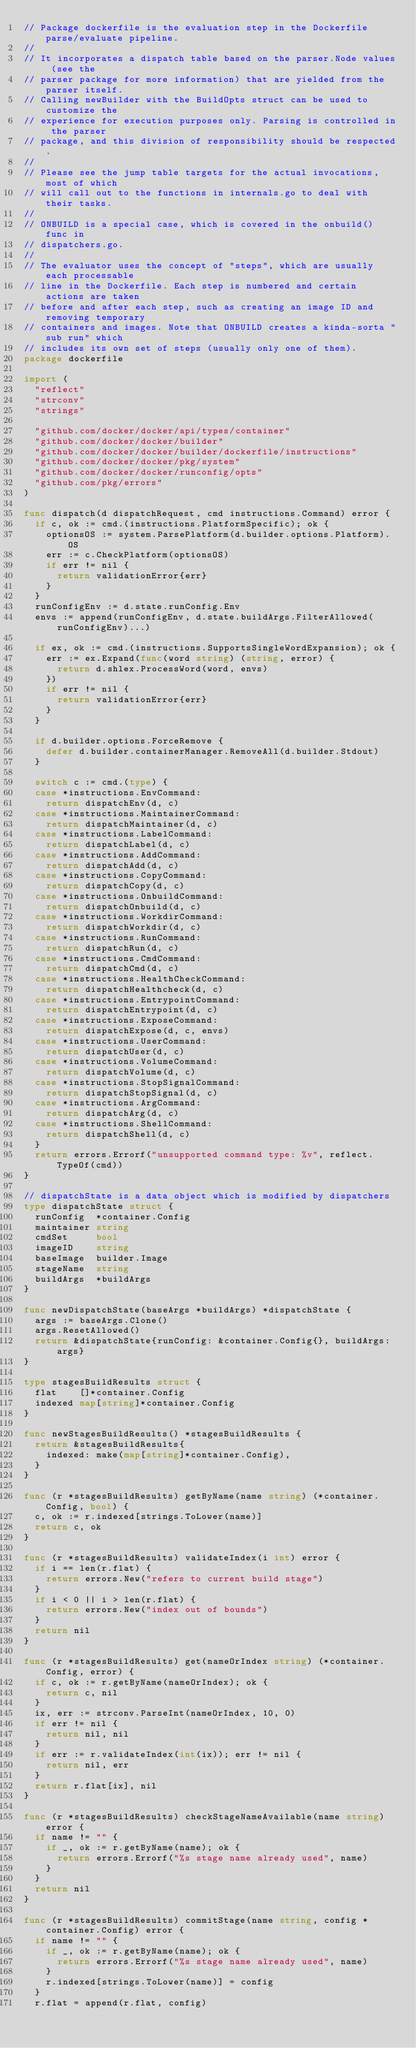Convert code to text. <code><loc_0><loc_0><loc_500><loc_500><_Go_>// Package dockerfile is the evaluation step in the Dockerfile parse/evaluate pipeline.
//
// It incorporates a dispatch table based on the parser.Node values (see the
// parser package for more information) that are yielded from the parser itself.
// Calling newBuilder with the BuildOpts struct can be used to customize the
// experience for execution purposes only. Parsing is controlled in the parser
// package, and this division of responsibility should be respected.
//
// Please see the jump table targets for the actual invocations, most of which
// will call out to the functions in internals.go to deal with their tasks.
//
// ONBUILD is a special case, which is covered in the onbuild() func in
// dispatchers.go.
//
// The evaluator uses the concept of "steps", which are usually each processable
// line in the Dockerfile. Each step is numbered and certain actions are taken
// before and after each step, such as creating an image ID and removing temporary
// containers and images. Note that ONBUILD creates a kinda-sorta "sub run" which
// includes its own set of steps (usually only one of them).
package dockerfile

import (
	"reflect"
	"strconv"
	"strings"

	"github.com/docker/docker/api/types/container"
	"github.com/docker/docker/builder"
	"github.com/docker/docker/builder/dockerfile/instructions"
	"github.com/docker/docker/pkg/system"
	"github.com/docker/docker/runconfig/opts"
	"github.com/pkg/errors"
)

func dispatch(d dispatchRequest, cmd instructions.Command) error {
	if c, ok := cmd.(instructions.PlatformSpecific); ok {
		optionsOS := system.ParsePlatform(d.builder.options.Platform).OS
		err := c.CheckPlatform(optionsOS)
		if err != nil {
			return validationError{err}
		}
	}
	runConfigEnv := d.state.runConfig.Env
	envs := append(runConfigEnv, d.state.buildArgs.FilterAllowed(runConfigEnv)...)

	if ex, ok := cmd.(instructions.SupportsSingleWordExpansion); ok {
		err := ex.Expand(func(word string) (string, error) {
			return d.shlex.ProcessWord(word, envs)
		})
		if err != nil {
			return validationError{err}
		}
	}

	if d.builder.options.ForceRemove {
		defer d.builder.containerManager.RemoveAll(d.builder.Stdout)
	}

	switch c := cmd.(type) {
	case *instructions.EnvCommand:
		return dispatchEnv(d, c)
	case *instructions.MaintainerCommand:
		return dispatchMaintainer(d, c)
	case *instructions.LabelCommand:
		return dispatchLabel(d, c)
	case *instructions.AddCommand:
		return dispatchAdd(d, c)
	case *instructions.CopyCommand:
		return dispatchCopy(d, c)
	case *instructions.OnbuildCommand:
		return dispatchOnbuild(d, c)
	case *instructions.WorkdirCommand:
		return dispatchWorkdir(d, c)
	case *instructions.RunCommand:
		return dispatchRun(d, c)
	case *instructions.CmdCommand:
		return dispatchCmd(d, c)
	case *instructions.HealthCheckCommand:
		return dispatchHealthcheck(d, c)
	case *instructions.EntrypointCommand:
		return dispatchEntrypoint(d, c)
	case *instructions.ExposeCommand:
		return dispatchExpose(d, c, envs)
	case *instructions.UserCommand:
		return dispatchUser(d, c)
	case *instructions.VolumeCommand:
		return dispatchVolume(d, c)
	case *instructions.StopSignalCommand:
		return dispatchStopSignal(d, c)
	case *instructions.ArgCommand:
		return dispatchArg(d, c)
	case *instructions.ShellCommand:
		return dispatchShell(d, c)
	}
	return errors.Errorf("unsupported command type: %v", reflect.TypeOf(cmd))
}

// dispatchState is a data object which is modified by dispatchers
type dispatchState struct {
	runConfig  *container.Config
	maintainer string
	cmdSet     bool
	imageID    string
	baseImage  builder.Image
	stageName  string
	buildArgs  *buildArgs
}

func newDispatchState(baseArgs *buildArgs) *dispatchState {
	args := baseArgs.Clone()
	args.ResetAllowed()
	return &dispatchState{runConfig: &container.Config{}, buildArgs: args}
}

type stagesBuildResults struct {
	flat    []*container.Config
	indexed map[string]*container.Config
}

func newStagesBuildResults() *stagesBuildResults {
	return &stagesBuildResults{
		indexed: make(map[string]*container.Config),
	}
}

func (r *stagesBuildResults) getByName(name string) (*container.Config, bool) {
	c, ok := r.indexed[strings.ToLower(name)]
	return c, ok
}

func (r *stagesBuildResults) validateIndex(i int) error {
	if i == len(r.flat) {
		return errors.New("refers to current build stage")
	}
	if i < 0 || i > len(r.flat) {
		return errors.New("index out of bounds")
	}
	return nil
}

func (r *stagesBuildResults) get(nameOrIndex string) (*container.Config, error) {
	if c, ok := r.getByName(nameOrIndex); ok {
		return c, nil
	}
	ix, err := strconv.ParseInt(nameOrIndex, 10, 0)
	if err != nil {
		return nil, nil
	}
	if err := r.validateIndex(int(ix)); err != nil {
		return nil, err
	}
	return r.flat[ix], nil
}

func (r *stagesBuildResults) checkStageNameAvailable(name string) error {
	if name != "" {
		if _, ok := r.getByName(name); ok {
			return errors.Errorf("%s stage name already used", name)
		}
	}
	return nil
}

func (r *stagesBuildResults) commitStage(name string, config *container.Config) error {
	if name != "" {
		if _, ok := r.getByName(name); ok {
			return errors.Errorf("%s stage name already used", name)
		}
		r.indexed[strings.ToLower(name)] = config
	}
	r.flat = append(r.flat, config)</code> 